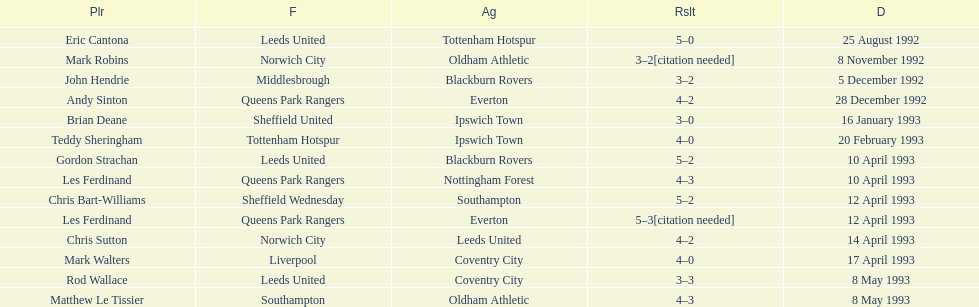Name the players for tottenham hotspur. Teddy Sheringham. 